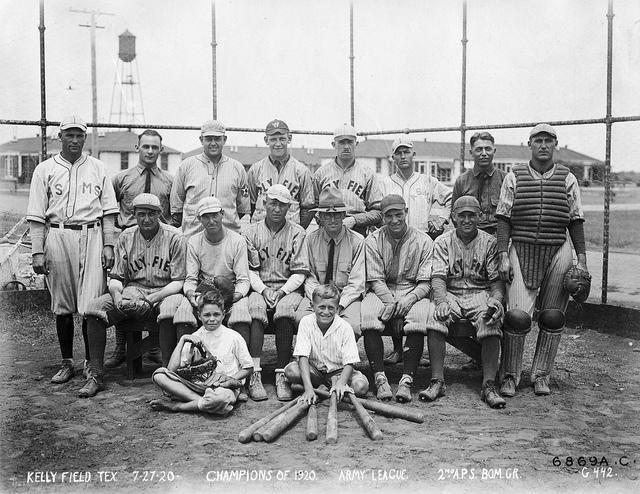How many people can you see?
Give a very brief answer. 14. How many chairs are on the beach?
Give a very brief answer. 0. 